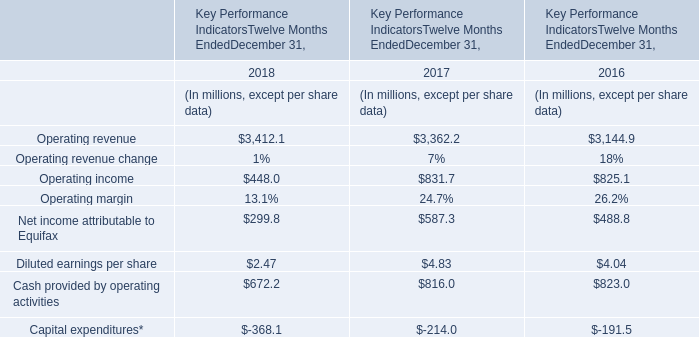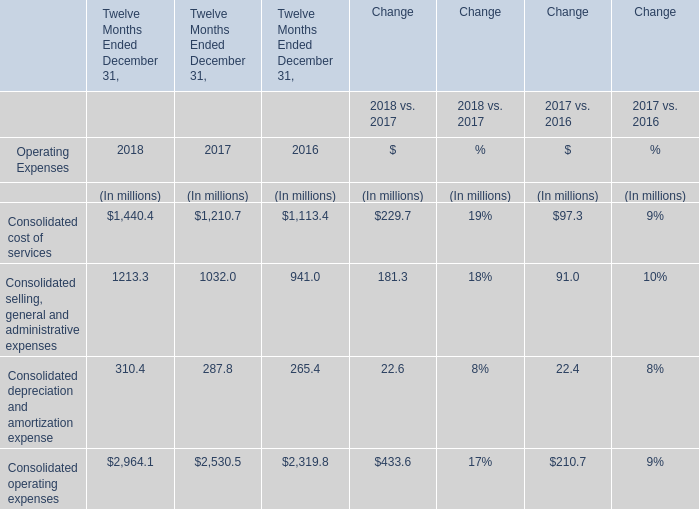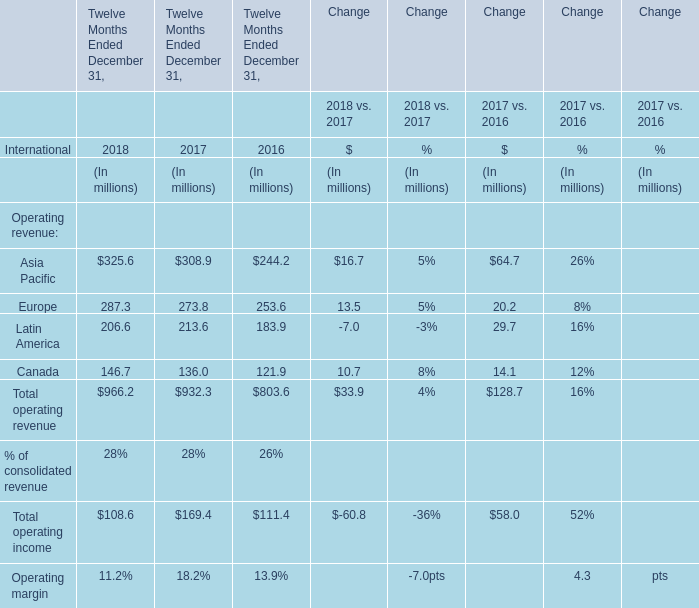What's the sum of the Consolidated cost of services for Twelve Months Ended December 31, in the years where Operating revenue is positive? (in million) 
Computations: ((1440.4 + 1210.7) + 1113.4)
Answer: 3764.5. 